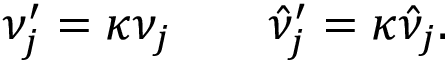<formula> <loc_0><loc_0><loc_500><loc_500>\nu _ { j } ^ { \prime } = \kappa \nu _ { j } \quad \hat { \nu } _ { j } ^ { \prime } = \kappa \hat { \nu } _ { j } .</formula> 